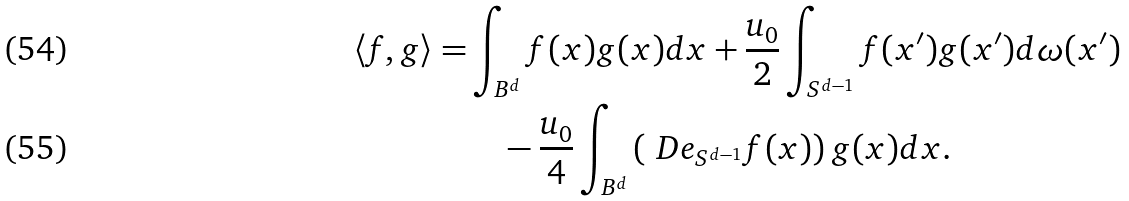<formula> <loc_0><loc_0><loc_500><loc_500>\langle f , g \rangle = & \int _ { B ^ { d } } f ( x ) g ( x ) d x + \frac { u _ { 0 } } { 2 } \int _ { S ^ { d - 1 } } f ( x ^ { \prime } ) g ( x ^ { \prime } ) d \omega ( x ^ { \prime } ) \\ & \quad - \frac { u _ { 0 } } { 4 } \int _ { B ^ { d } } \left ( \ D e _ { S ^ { d - 1 } } f ( x ) \right ) g ( x ) d x .</formula> 